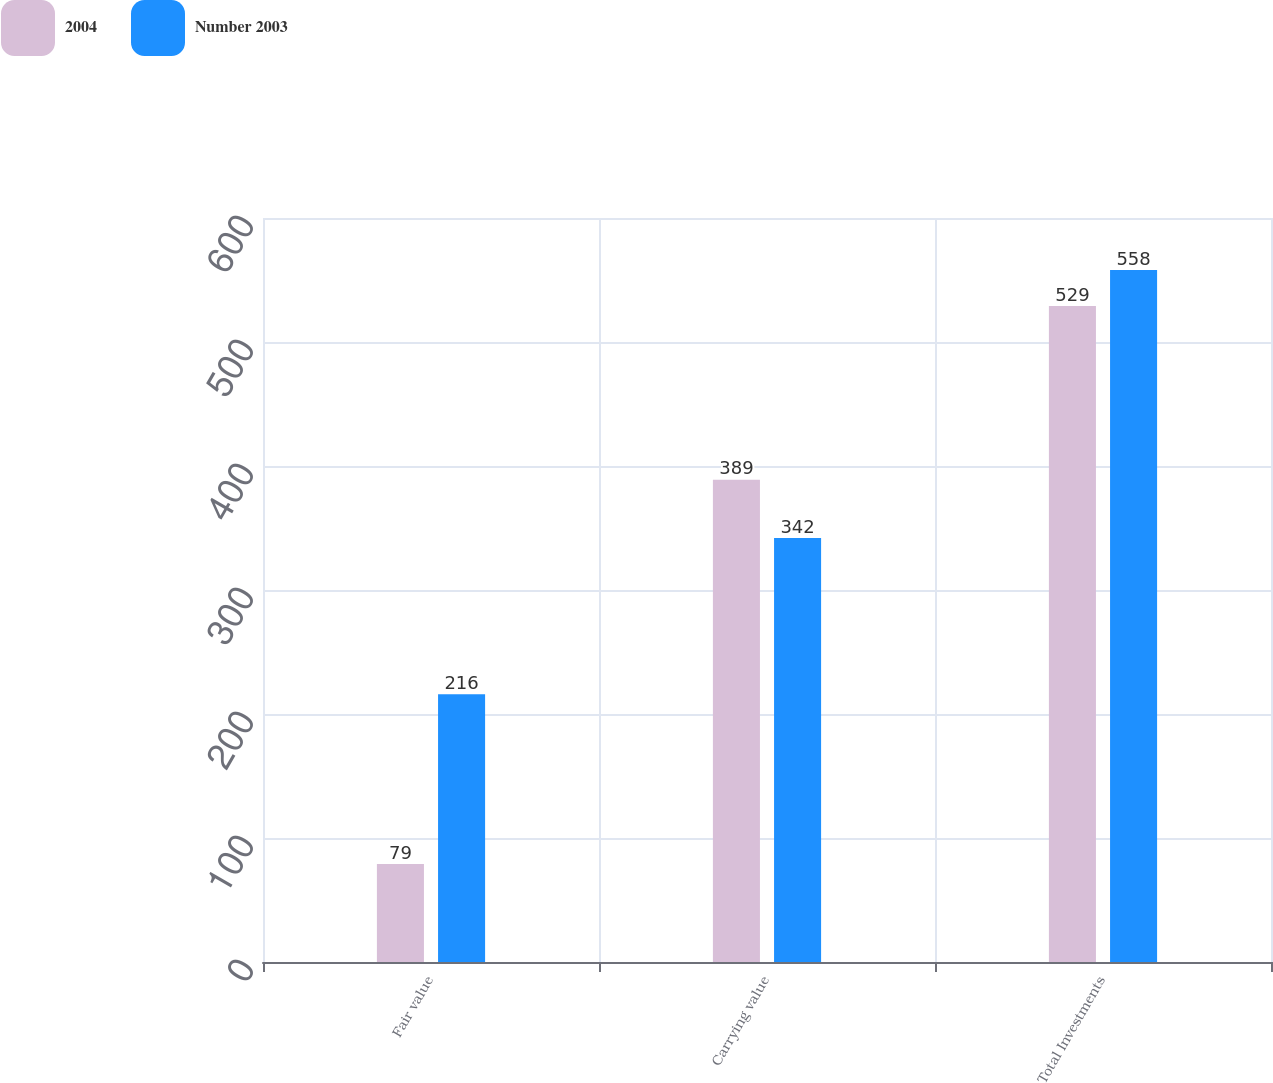Convert chart to OTSL. <chart><loc_0><loc_0><loc_500><loc_500><stacked_bar_chart><ecel><fcel>Fair value<fcel>Carrying value<fcel>Total Investments<nl><fcel>2004<fcel>79<fcel>389<fcel>529<nl><fcel>Number 2003<fcel>216<fcel>342<fcel>558<nl></chart> 